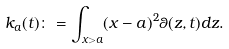Convert formula to latex. <formula><loc_0><loc_0><loc_500><loc_500>k _ { a } ( t ) \colon = \int _ { x > a } ( x - a ) ^ { 2 } \theta ( z , t ) d z .</formula> 